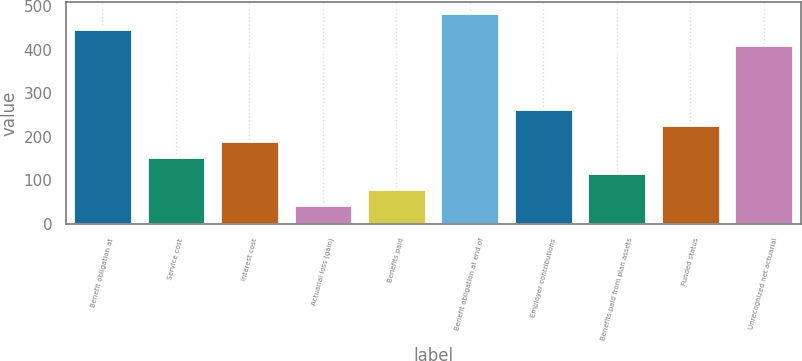Convert chart. <chart><loc_0><loc_0><loc_500><loc_500><bar_chart><fcel>Benefit obligation at<fcel>Service cost<fcel>Interest cost<fcel>Actuarial loss (gain)<fcel>Benefits paid<fcel>Benefit obligation at end of<fcel>Employer contributions<fcel>Benefits paid from plan assets<fcel>Funded status<fcel>Unrecognized net actuarial<nl><fcel>447.84<fcel>154.08<fcel>190.8<fcel>43.92<fcel>80.64<fcel>484.56<fcel>264.24<fcel>117.36<fcel>227.52<fcel>411.12<nl></chart> 